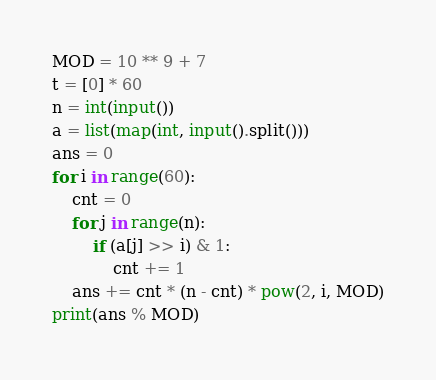Convert code to text. <code><loc_0><loc_0><loc_500><loc_500><_Python_>MOD = 10 ** 9 + 7
t = [0] * 60
n = int(input())
a = list(map(int, input().split()))
ans = 0
for i in range(60):
    cnt = 0
    for j in range(n):
        if (a[j] >> i) & 1:
            cnt += 1
    ans += cnt * (n - cnt) * pow(2, i, MOD)
print(ans % MOD)
</code> 